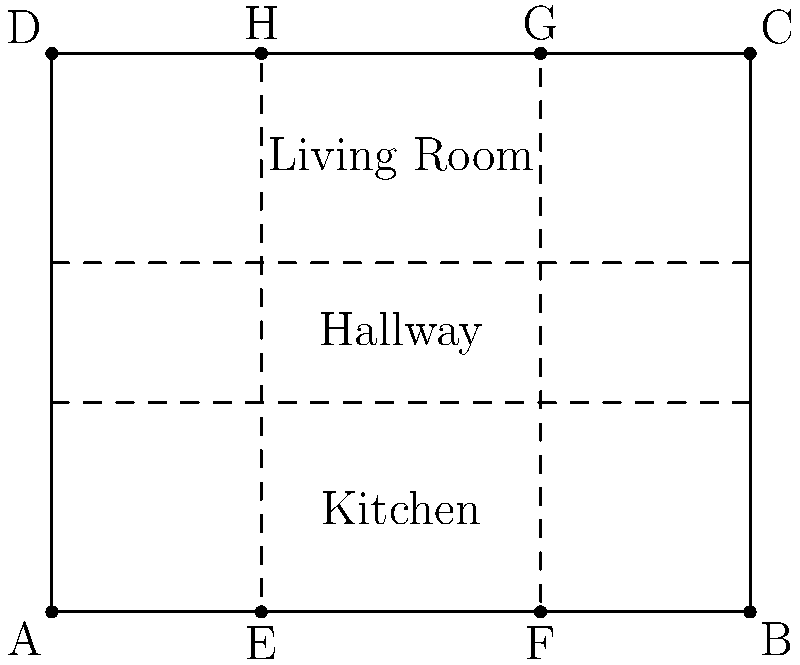In the house diagram above, you want to create "safe zones" for your two young boys to play freely and "off-limits areas" where they need permission to enter. If the living room and kitchen are designated as safe zones, and the hallway is off-limits, what is the total perimeter of the safe zones in terms of the house's width (AB) and height (AD)? To solve this problem, we'll follow these steps:

1. Identify the safe zones: Living room and kitchen.
2. Calculate the perimeter of each safe zone.
3. Add the perimeters together.

Let's define the variables:
- Width of the house: AB = w
- Height of the house: AD = h

Step 1: Living room dimensions
- Width: EF = w - 2(AE) = 0.4w (since EF is 40% of AB)
- Height: HG = 0.375h (since HG is 3/8 of AD)

Step 2: Kitchen dimensions
- Width: EF = 0.4w (same as living room)
- Height: FJ = 0.375h (since FJ is 3/8 of AD)

Step 3: Calculate perimeters
Living room perimeter = 2(0.4w) + 2(0.375h) = 0.8w + 0.75h
Kitchen perimeter = 2(0.4w) + 2(0.375h) = 0.8w + 0.75h

Step 4: Total perimeter of safe zones
Total perimeter = Living room perimeter + Kitchen perimeter
                = (0.8w + 0.75h) + (0.8w + 0.75h)
                = 1.6w + 1.5h

Therefore, the total perimeter of the safe zones is $1.6w + 1.5h$, where $w$ is the width of the house (AB) and $h$ is the height of the house (AD).
Answer: $1.6w + 1.5h$ 